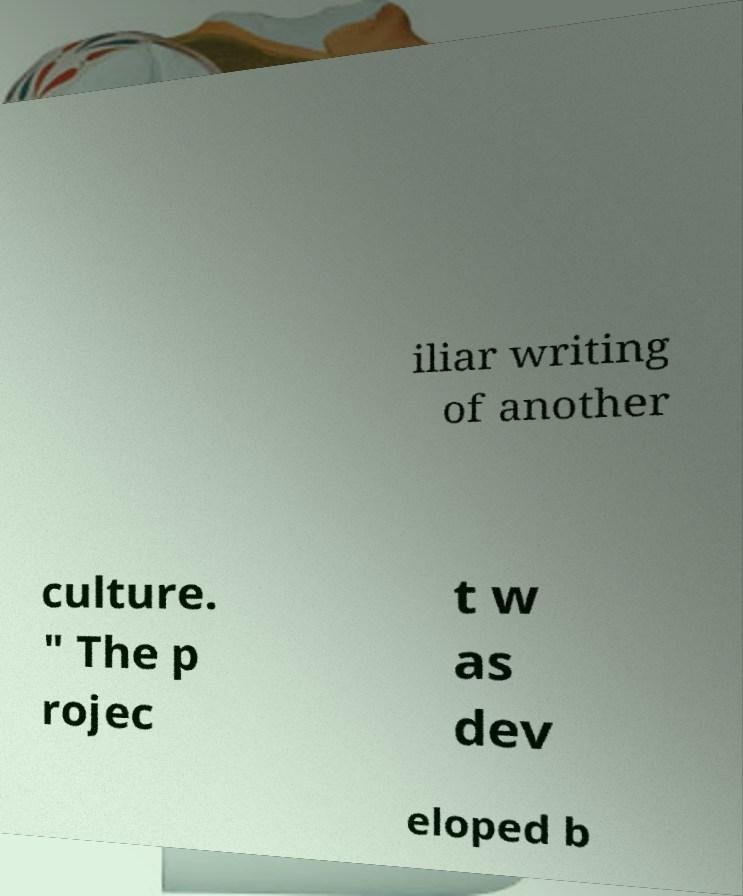Could you assist in decoding the text presented in this image and type it out clearly? iliar writing of another culture. " The p rojec t w as dev eloped b 